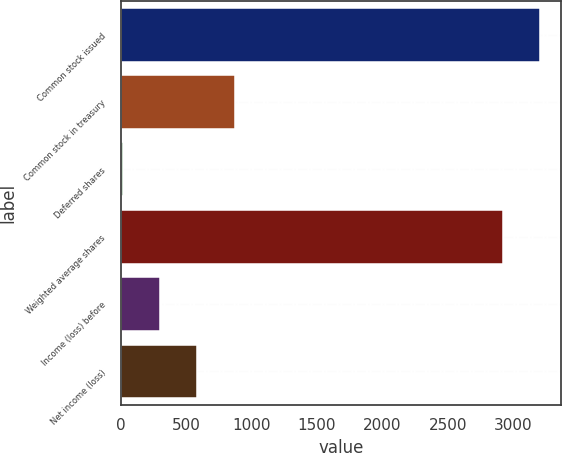Convert chart. <chart><loc_0><loc_0><loc_500><loc_500><bar_chart><fcel>Common stock issued<fcel>Common stock in treasury<fcel>Deferred shares<fcel>Weighted average shares<fcel>Income (loss) before<fcel>Net income (loss)<nl><fcel>3205.6<fcel>871.4<fcel>14<fcel>2919.8<fcel>299.8<fcel>585.6<nl></chart> 